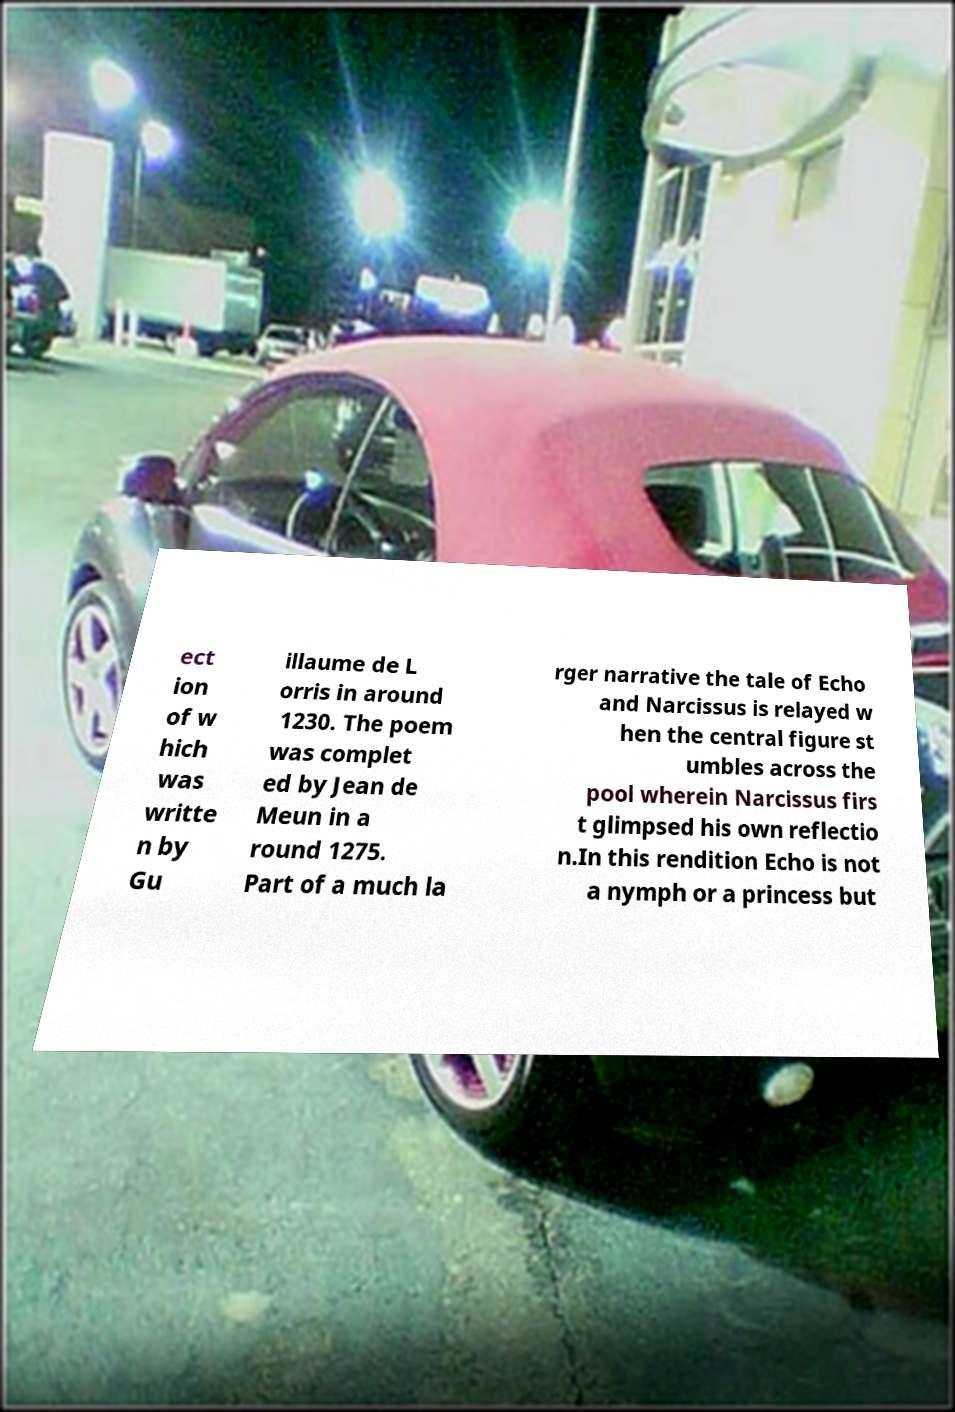For documentation purposes, I need the text within this image transcribed. Could you provide that? ect ion of w hich was writte n by Gu illaume de L orris in around 1230. The poem was complet ed by Jean de Meun in a round 1275. Part of a much la rger narrative the tale of Echo and Narcissus is relayed w hen the central figure st umbles across the pool wherein Narcissus firs t glimpsed his own reflectio n.In this rendition Echo is not a nymph or a princess but 